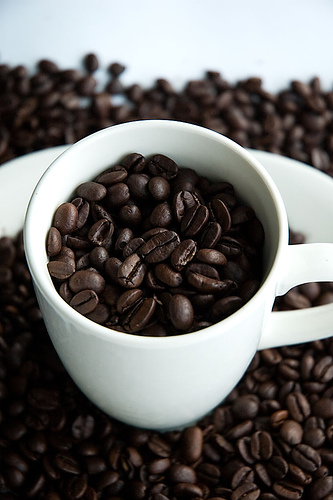<image>
Is there a coffee beans under the mug? Yes. The coffee beans is positioned underneath the mug, with the mug above it in the vertical space. Where is the bean in relation to the plate? Is it above the plate? Yes. The bean is positioned above the plate in the vertical space, higher up in the scene. Is there a beans above the beans? Yes. The beans is positioned above the beans in the vertical space, higher up in the scene. 